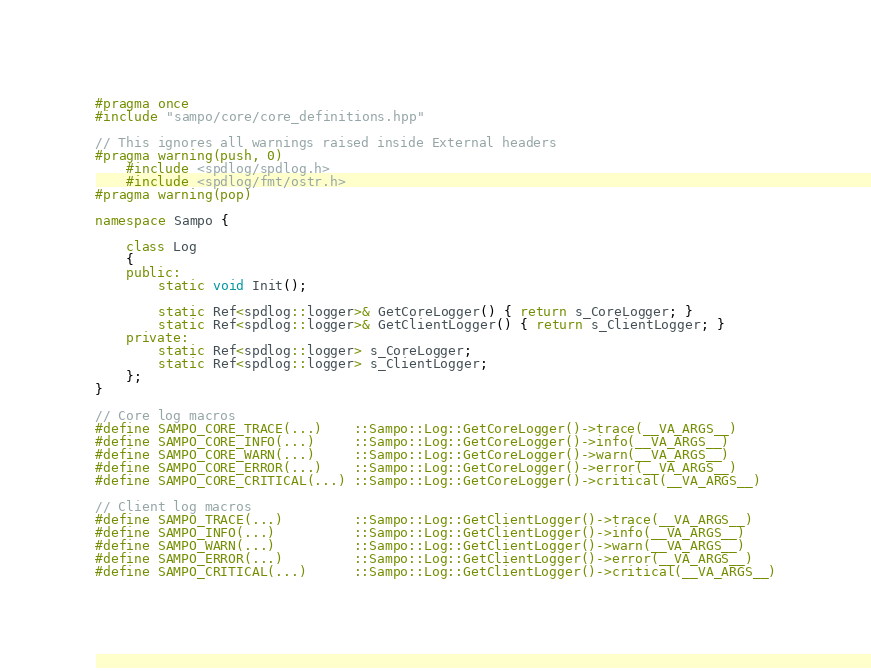<code> <loc_0><loc_0><loc_500><loc_500><_C++_>#pragma once
#include "sampo/core/core_definitions.hpp"

// This ignores all warnings raised inside External headers
#pragma warning(push, 0)
    #include <spdlog/spdlog.h>
    #include <spdlog/fmt/ostr.h>
#pragma warning(pop)

namespace Sampo {

    class Log
    {
    public:
        static void Init();

        static Ref<spdlog::logger>& GetCoreLogger() { return s_CoreLogger; }
        static Ref<spdlog::logger>& GetClientLogger() { return s_ClientLogger; }
    private:
        static Ref<spdlog::logger> s_CoreLogger;
        static Ref<spdlog::logger> s_ClientLogger;
    };
}

// Core log macros
#define SAMPO_CORE_TRACE(...)    ::Sampo::Log::GetCoreLogger()->trace(__VA_ARGS__)
#define SAMPO_CORE_INFO(...)     ::Sampo::Log::GetCoreLogger()->info(__VA_ARGS__)
#define SAMPO_CORE_WARN(...)     ::Sampo::Log::GetCoreLogger()->warn(__VA_ARGS__)
#define SAMPO_CORE_ERROR(...)    ::Sampo::Log::GetCoreLogger()->error(__VA_ARGS__)
#define SAMPO_CORE_CRITICAL(...) ::Sampo::Log::GetCoreLogger()->critical(__VA_ARGS__)

// Client log macros
#define SAMPO_TRACE(...)         ::Sampo::Log::GetClientLogger()->trace(__VA_ARGS__)
#define SAMPO_INFO(...)          ::Sampo::Log::GetClientLogger()->info(__VA_ARGS__)
#define SAMPO_WARN(...)          ::Sampo::Log::GetClientLogger()->warn(__VA_ARGS__)
#define SAMPO_ERROR(...)         ::Sampo::Log::GetClientLogger()->error(__VA_ARGS__)
#define SAMPO_CRITICAL(...)      ::Sampo::Log::GetClientLogger()->critical(__VA_ARGS__)
</code> 